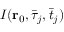<formula> <loc_0><loc_0><loc_500><loc_500>I ( r _ { 0 } , \bar { \tau } _ { j } , \bar { t } _ { j } )</formula> 